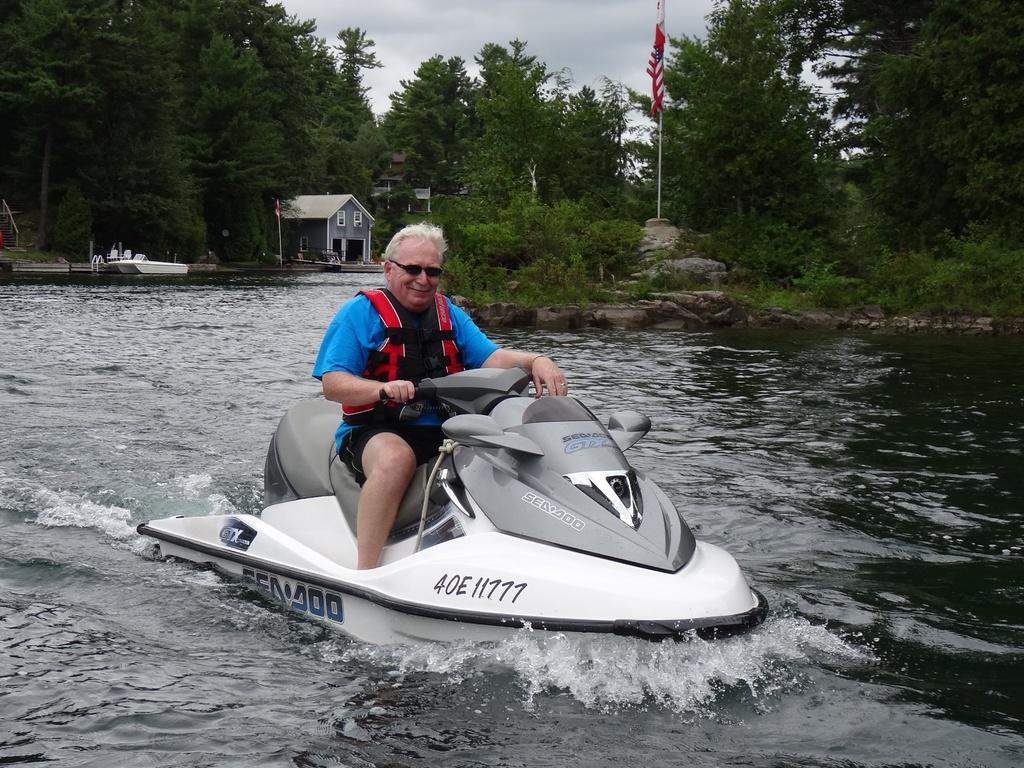What is the license number on the jet ski?
Your answer should be very brief. 40e11777. What is the hull number of the jet ski?
Your response must be concise. 40e11777. 